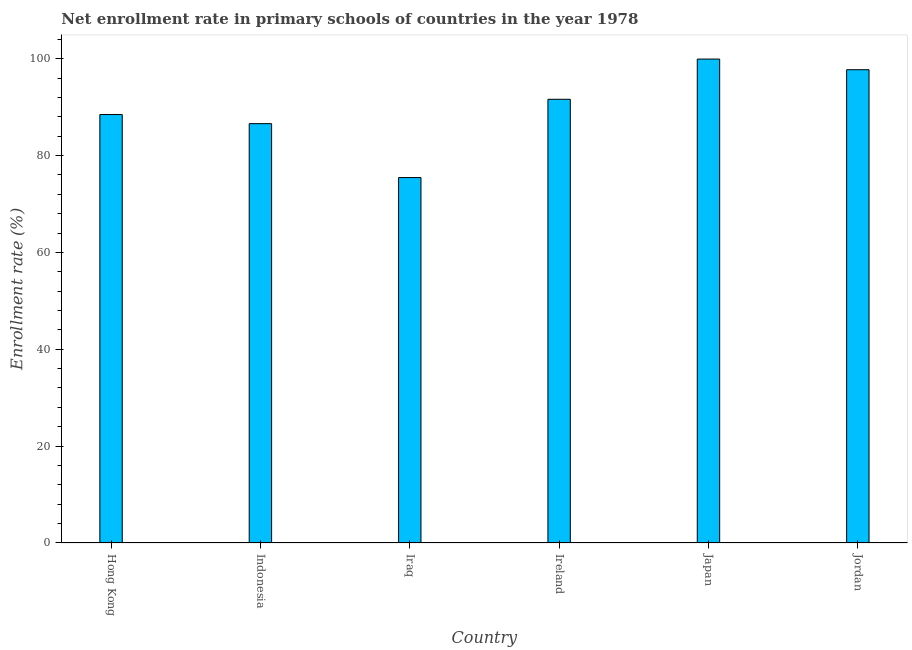Does the graph contain any zero values?
Your answer should be compact. No. What is the title of the graph?
Keep it short and to the point. Net enrollment rate in primary schools of countries in the year 1978. What is the label or title of the Y-axis?
Your answer should be compact. Enrollment rate (%). What is the net enrollment rate in primary schools in Indonesia?
Offer a very short reply. 86.58. Across all countries, what is the maximum net enrollment rate in primary schools?
Provide a short and direct response. 99.91. Across all countries, what is the minimum net enrollment rate in primary schools?
Your response must be concise. 75.45. In which country was the net enrollment rate in primary schools maximum?
Your answer should be compact. Japan. In which country was the net enrollment rate in primary schools minimum?
Offer a very short reply. Iraq. What is the sum of the net enrollment rate in primary schools?
Provide a succinct answer. 539.72. What is the difference between the net enrollment rate in primary schools in Iraq and Ireland?
Offer a very short reply. -16.16. What is the average net enrollment rate in primary schools per country?
Keep it short and to the point. 89.95. What is the median net enrollment rate in primary schools?
Offer a terse response. 90.03. In how many countries, is the net enrollment rate in primary schools greater than 12 %?
Give a very brief answer. 6. What is the ratio of the net enrollment rate in primary schools in Indonesia to that in Ireland?
Offer a very short reply. 0.94. Is the difference between the net enrollment rate in primary schools in Iraq and Japan greater than the difference between any two countries?
Your answer should be compact. Yes. What is the difference between the highest and the second highest net enrollment rate in primary schools?
Make the answer very short. 2.2. Is the sum of the net enrollment rate in primary schools in Iraq and Jordan greater than the maximum net enrollment rate in primary schools across all countries?
Offer a very short reply. Yes. What is the difference between the highest and the lowest net enrollment rate in primary schools?
Your response must be concise. 24.46. In how many countries, is the net enrollment rate in primary schools greater than the average net enrollment rate in primary schools taken over all countries?
Offer a very short reply. 3. How many bars are there?
Make the answer very short. 6. How many countries are there in the graph?
Keep it short and to the point. 6. What is the Enrollment rate (%) of Hong Kong?
Provide a short and direct response. 88.46. What is the Enrollment rate (%) of Indonesia?
Your response must be concise. 86.58. What is the Enrollment rate (%) of Iraq?
Provide a succinct answer. 75.45. What is the Enrollment rate (%) in Ireland?
Provide a succinct answer. 91.61. What is the Enrollment rate (%) of Japan?
Give a very brief answer. 99.91. What is the Enrollment rate (%) of Jordan?
Provide a succinct answer. 97.71. What is the difference between the Enrollment rate (%) in Hong Kong and Indonesia?
Your answer should be very brief. 1.88. What is the difference between the Enrollment rate (%) in Hong Kong and Iraq?
Keep it short and to the point. 13.01. What is the difference between the Enrollment rate (%) in Hong Kong and Ireland?
Provide a succinct answer. -3.15. What is the difference between the Enrollment rate (%) in Hong Kong and Japan?
Keep it short and to the point. -11.45. What is the difference between the Enrollment rate (%) in Hong Kong and Jordan?
Give a very brief answer. -9.25. What is the difference between the Enrollment rate (%) in Indonesia and Iraq?
Offer a very short reply. 11.13. What is the difference between the Enrollment rate (%) in Indonesia and Ireland?
Provide a succinct answer. -5.03. What is the difference between the Enrollment rate (%) in Indonesia and Japan?
Offer a very short reply. -13.33. What is the difference between the Enrollment rate (%) in Indonesia and Jordan?
Offer a terse response. -11.13. What is the difference between the Enrollment rate (%) in Iraq and Ireland?
Provide a succinct answer. -16.16. What is the difference between the Enrollment rate (%) in Iraq and Japan?
Your response must be concise. -24.46. What is the difference between the Enrollment rate (%) in Iraq and Jordan?
Provide a short and direct response. -22.26. What is the difference between the Enrollment rate (%) in Ireland and Japan?
Ensure brevity in your answer.  -8.3. What is the difference between the Enrollment rate (%) in Ireland and Jordan?
Make the answer very short. -6.1. What is the difference between the Enrollment rate (%) in Japan and Jordan?
Provide a short and direct response. 2.2. What is the ratio of the Enrollment rate (%) in Hong Kong to that in Iraq?
Give a very brief answer. 1.17. What is the ratio of the Enrollment rate (%) in Hong Kong to that in Japan?
Your response must be concise. 0.89. What is the ratio of the Enrollment rate (%) in Hong Kong to that in Jordan?
Provide a succinct answer. 0.91. What is the ratio of the Enrollment rate (%) in Indonesia to that in Iraq?
Offer a very short reply. 1.15. What is the ratio of the Enrollment rate (%) in Indonesia to that in Ireland?
Your answer should be very brief. 0.94. What is the ratio of the Enrollment rate (%) in Indonesia to that in Japan?
Your answer should be compact. 0.87. What is the ratio of the Enrollment rate (%) in Indonesia to that in Jordan?
Your answer should be very brief. 0.89. What is the ratio of the Enrollment rate (%) in Iraq to that in Ireland?
Ensure brevity in your answer.  0.82. What is the ratio of the Enrollment rate (%) in Iraq to that in Japan?
Your answer should be very brief. 0.76. What is the ratio of the Enrollment rate (%) in Iraq to that in Jordan?
Offer a very short reply. 0.77. What is the ratio of the Enrollment rate (%) in Ireland to that in Japan?
Ensure brevity in your answer.  0.92. What is the ratio of the Enrollment rate (%) in Ireland to that in Jordan?
Offer a terse response. 0.94. 